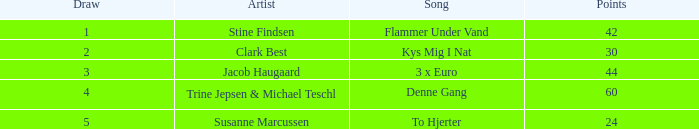What is the draw containing points more than 44 and a spot bigger than 1? None. 